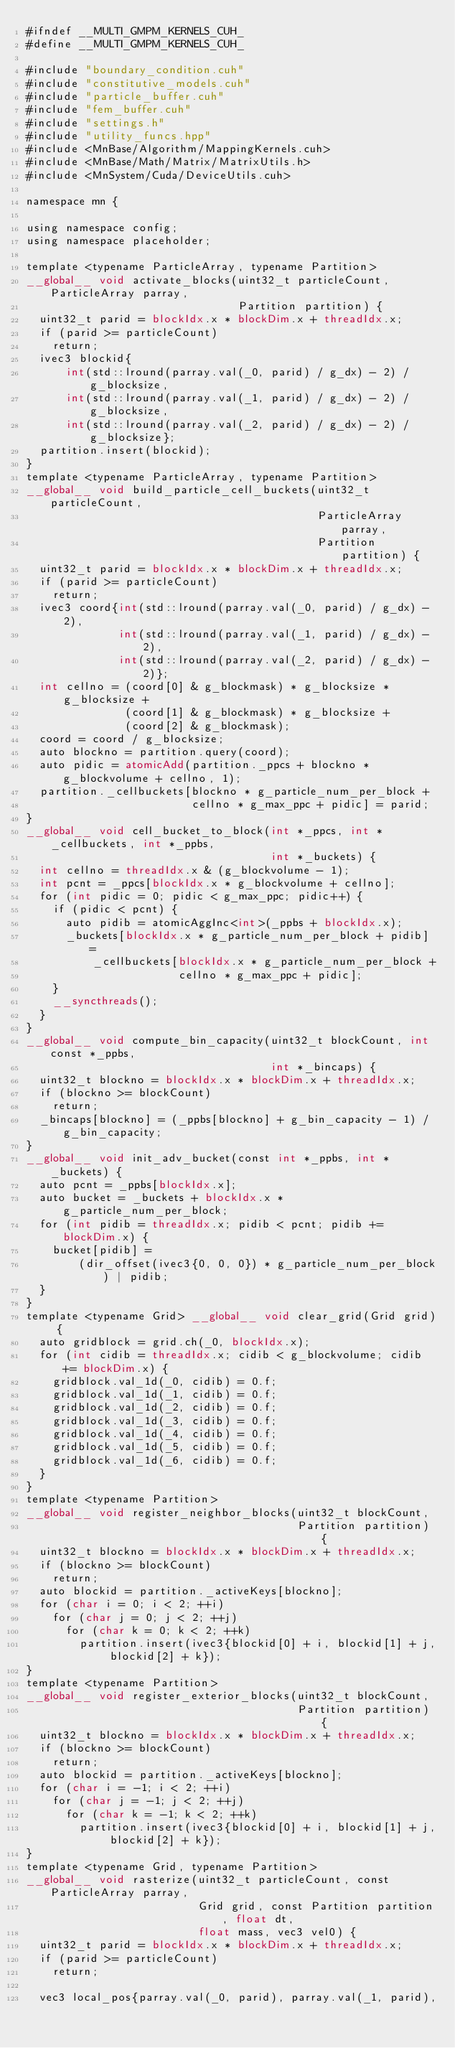Convert code to text. <code><loc_0><loc_0><loc_500><loc_500><_Cuda_>#ifndef __MULTI_GMPM_KERNELS_CUH_
#define __MULTI_GMPM_KERNELS_CUH_

#include "boundary_condition.cuh"
#include "constitutive_models.cuh"
#include "particle_buffer.cuh"
#include "fem_buffer.cuh"
#include "settings.h"
#include "utility_funcs.hpp"
#include <MnBase/Algorithm/MappingKernels.cuh>
#include <MnBase/Math/Matrix/MatrixUtils.h>
#include <MnSystem/Cuda/DeviceUtils.cuh>

namespace mn {

using namespace config;
using namespace placeholder;

template <typename ParticleArray, typename Partition>
__global__ void activate_blocks(uint32_t particleCount, ParticleArray parray,
                                Partition partition) {
  uint32_t parid = blockIdx.x * blockDim.x + threadIdx.x;
  if (parid >= particleCount)
    return;
  ivec3 blockid{
      int(std::lround(parray.val(_0, parid) / g_dx) - 2) / g_blocksize,
      int(std::lround(parray.val(_1, parid) / g_dx) - 2) / g_blocksize,
      int(std::lround(parray.val(_2, parid) / g_dx) - 2) / g_blocksize};
  partition.insert(blockid);
}
template <typename ParticleArray, typename Partition>
__global__ void build_particle_cell_buckets(uint32_t particleCount,
                                            ParticleArray parray,
                                            Partition partition) {
  uint32_t parid = blockIdx.x * blockDim.x + threadIdx.x;
  if (parid >= particleCount)
    return;
  ivec3 coord{int(std::lround(parray.val(_0, parid) / g_dx) - 2),
              int(std::lround(parray.val(_1, parid) / g_dx) - 2),
              int(std::lround(parray.val(_2, parid) / g_dx) - 2)};
  int cellno = (coord[0] & g_blockmask) * g_blocksize * g_blocksize +
               (coord[1] & g_blockmask) * g_blocksize +
               (coord[2] & g_blockmask);
  coord = coord / g_blocksize;
  auto blockno = partition.query(coord);
  auto pidic = atomicAdd(partition._ppcs + blockno * g_blockvolume + cellno, 1);
  partition._cellbuckets[blockno * g_particle_num_per_block +
                         cellno * g_max_ppc + pidic] = parid;
}
__global__ void cell_bucket_to_block(int *_ppcs, int *_cellbuckets, int *_ppbs,
                                     int *_buckets) {
  int cellno = threadIdx.x & (g_blockvolume - 1);
  int pcnt = _ppcs[blockIdx.x * g_blockvolume + cellno];
  for (int pidic = 0; pidic < g_max_ppc; pidic++) {
    if (pidic < pcnt) {
      auto pidib = atomicAggInc<int>(_ppbs + blockIdx.x);
      _buckets[blockIdx.x * g_particle_num_per_block + pidib] =
          _cellbuckets[blockIdx.x * g_particle_num_per_block +
                       cellno * g_max_ppc + pidic];
    }
    __syncthreads();
  }
}
__global__ void compute_bin_capacity(uint32_t blockCount, int const *_ppbs,
                                     int *_bincaps) {
  uint32_t blockno = blockIdx.x * blockDim.x + threadIdx.x;
  if (blockno >= blockCount)
    return;
  _bincaps[blockno] = (_ppbs[blockno] + g_bin_capacity - 1) / g_bin_capacity;
}
__global__ void init_adv_bucket(const int *_ppbs, int *_buckets) {
  auto pcnt = _ppbs[blockIdx.x];
  auto bucket = _buckets + blockIdx.x * g_particle_num_per_block;
  for (int pidib = threadIdx.x; pidib < pcnt; pidib += blockDim.x) {
    bucket[pidib] =
        (dir_offset(ivec3{0, 0, 0}) * g_particle_num_per_block) | pidib;
  }
}
template <typename Grid> __global__ void clear_grid(Grid grid) {
  auto gridblock = grid.ch(_0, blockIdx.x);
  for (int cidib = threadIdx.x; cidib < g_blockvolume; cidib += blockDim.x) {
    gridblock.val_1d(_0, cidib) = 0.f;
    gridblock.val_1d(_1, cidib) = 0.f;
    gridblock.val_1d(_2, cidib) = 0.f;
    gridblock.val_1d(_3, cidib) = 0.f;
    gridblock.val_1d(_4, cidib) = 0.f;
    gridblock.val_1d(_5, cidib) = 0.f;
    gridblock.val_1d(_6, cidib) = 0.f;
  }
}
template <typename Partition>
__global__ void register_neighbor_blocks(uint32_t blockCount,
                                         Partition partition) {
  uint32_t blockno = blockIdx.x * blockDim.x + threadIdx.x;
  if (blockno >= blockCount)
    return;
  auto blockid = partition._activeKeys[blockno];
  for (char i = 0; i < 2; ++i)
    for (char j = 0; j < 2; ++j)
      for (char k = 0; k < 2; ++k)
        partition.insert(ivec3{blockid[0] + i, blockid[1] + j, blockid[2] + k});
}
template <typename Partition>
__global__ void register_exterior_blocks(uint32_t blockCount,
                                         Partition partition) {
  uint32_t blockno = blockIdx.x * blockDim.x + threadIdx.x;
  if (blockno >= blockCount)
    return;
  auto blockid = partition._activeKeys[blockno];
  for (char i = -1; i < 2; ++i)
    for (char j = -1; j < 2; ++j)
      for (char k = -1; k < 2; ++k)
        partition.insert(ivec3{blockid[0] + i, blockid[1] + j, blockid[2] + k});
}
template <typename Grid, typename Partition>
__global__ void rasterize(uint32_t particleCount, const ParticleArray parray,
                          Grid grid, const Partition partition, float dt,
                          float mass, vec3 vel0) {
  uint32_t parid = blockIdx.x * blockDim.x + threadIdx.x;
  if (parid >= particleCount)
    return;

  vec3 local_pos{parray.val(_0, parid), parray.val(_1, parid),</code> 